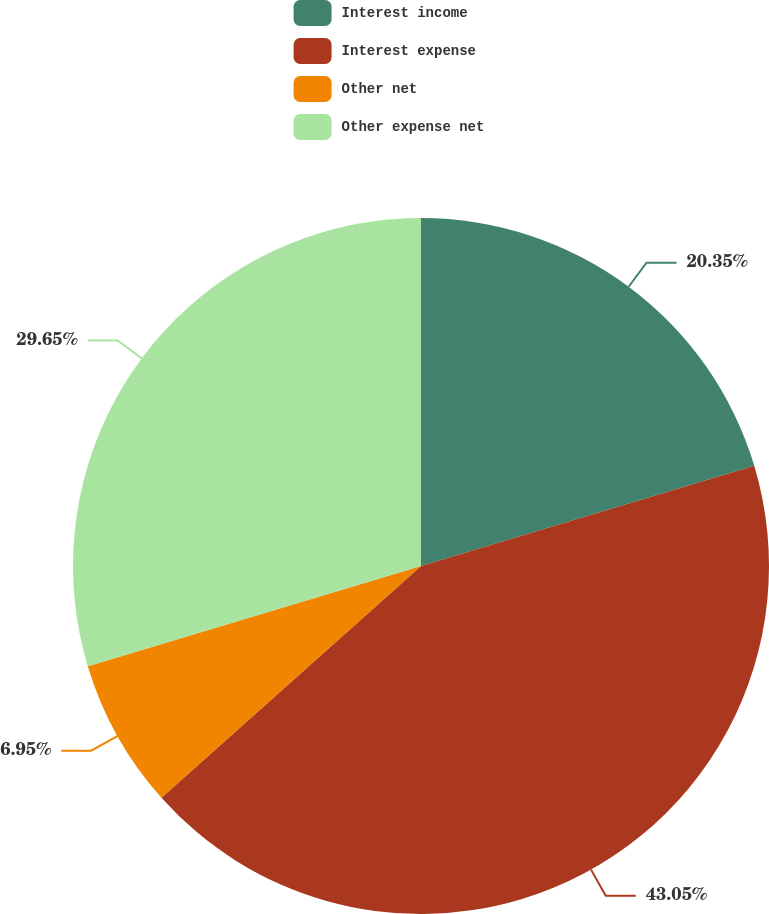Convert chart to OTSL. <chart><loc_0><loc_0><loc_500><loc_500><pie_chart><fcel>Interest income<fcel>Interest expense<fcel>Other net<fcel>Other expense net<nl><fcel>20.35%<fcel>43.05%<fcel>6.95%<fcel>29.65%<nl></chart> 